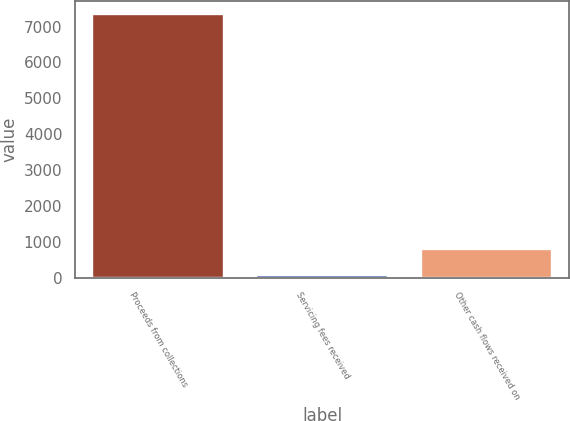<chart> <loc_0><loc_0><loc_500><loc_500><bar_chart><fcel>Proceeds from collections<fcel>Servicing fees received<fcel>Other cash flows received on<nl><fcel>7341.4<fcel>64.1<fcel>791.83<nl></chart> 